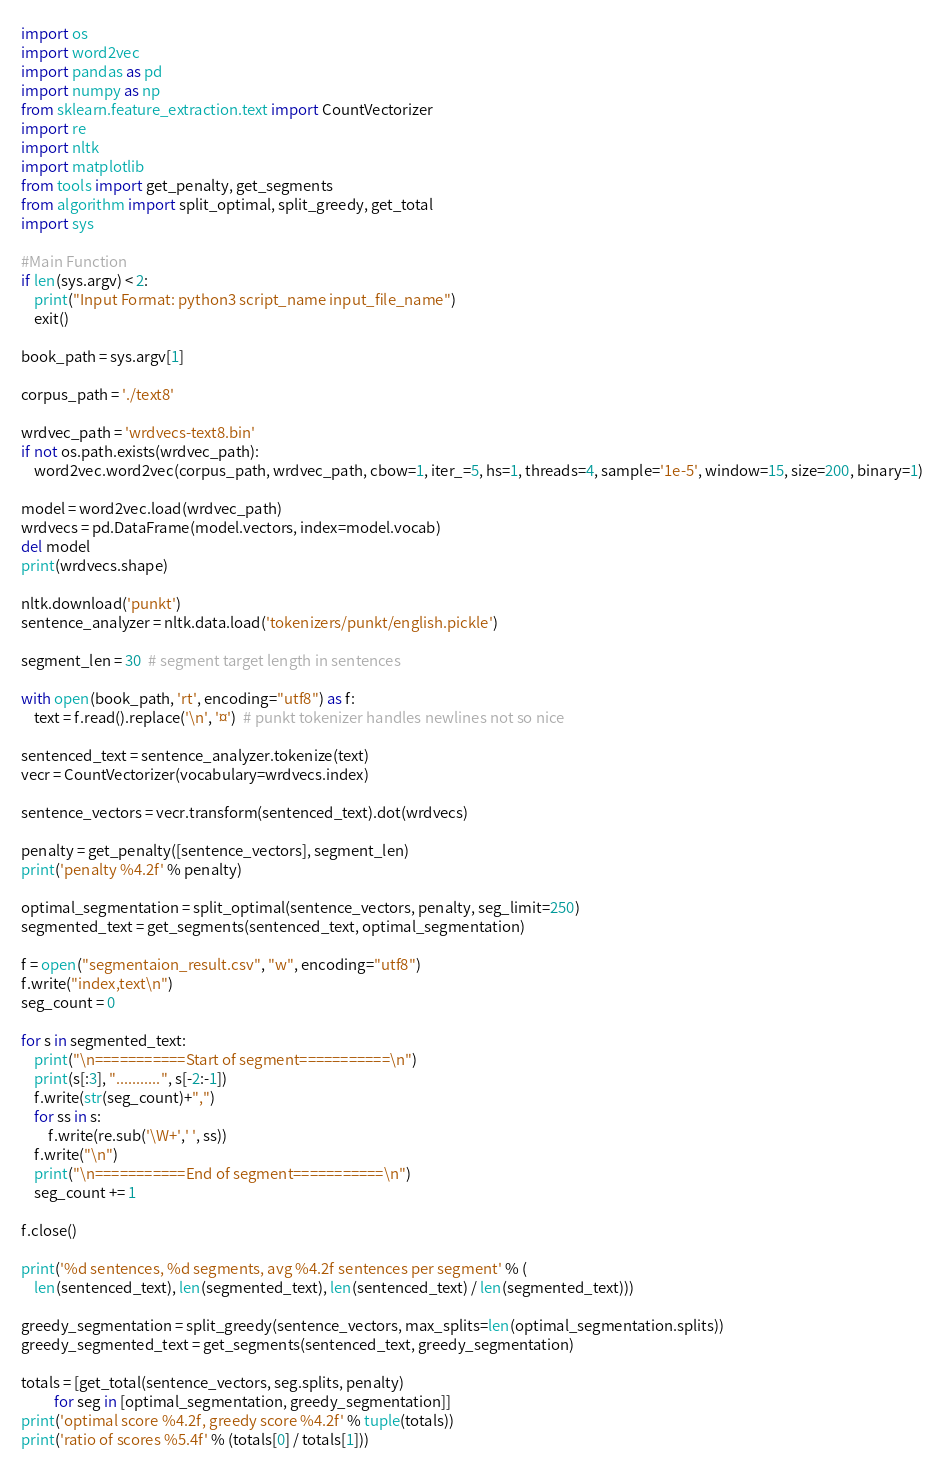Convert code to text. <code><loc_0><loc_0><loc_500><loc_500><_Python_>import os
import word2vec
import pandas as pd
import numpy as np
from sklearn.feature_extraction.text import CountVectorizer
import re
import nltk
import matplotlib
from tools import get_penalty, get_segments
from algorithm import split_optimal, split_greedy, get_total
import sys

#Main Function
if len(sys.argv) < 2:
    print("Input Format: python3 script_name input_file_name")
    exit()
    
book_path = sys.argv[1]

corpus_path = './text8'  

wrdvec_path = 'wrdvecs-text8.bin'
if not os.path.exists(wrdvec_path):
    word2vec.word2vec(corpus_path, wrdvec_path, cbow=1, iter_=5, hs=1, threads=4, sample='1e-5', window=15, size=200, binary=1)

model = word2vec.load(wrdvec_path)
wrdvecs = pd.DataFrame(model.vectors, index=model.vocab)
del model
print(wrdvecs.shape)

nltk.download('punkt')
sentence_analyzer = nltk.data.load('tokenizers/punkt/english.pickle')

segment_len = 30  # segment target length in sentences

with open(book_path, 'rt', encoding="utf8") as f:
    text = f.read().replace('\n', '¤')  # punkt tokenizer handles newlines not so nice

sentenced_text = sentence_analyzer.tokenize(text)
vecr = CountVectorizer(vocabulary=wrdvecs.index)

sentence_vectors = vecr.transform(sentenced_text).dot(wrdvecs)

penalty = get_penalty([sentence_vectors], segment_len)
print('penalty %4.2f' % penalty)

optimal_segmentation = split_optimal(sentence_vectors, penalty, seg_limit=250)
segmented_text = get_segments(sentenced_text, optimal_segmentation)

f = open("segmentaion_result.csv", "w", encoding="utf8")
f.write("index,text\n")
seg_count = 0

for s in segmented_text:
    print("\n===========Start of segment===========\n")
    print(s[:3], "...........", s[-2:-1])
    f.write(str(seg_count)+",")
    for ss in s:
        f.write(re.sub('\W+',' ', ss))
    f.write("\n")    
    print("\n===========End of segment===========\n")
    seg_count += 1

f.close()

print('%d sentences, %d segments, avg %4.2f sentences per segment' % (
    len(sentenced_text), len(segmented_text), len(sentenced_text) / len(segmented_text)))

greedy_segmentation = split_greedy(sentence_vectors, max_splits=len(optimal_segmentation.splits))
greedy_segmented_text = get_segments(sentenced_text, greedy_segmentation)

totals = [get_total(sentence_vectors, seg.splits, penalty) 
          for seg in [optimal_segmentation, greedy_segmentation]]
print('optimal score %4.2f, greedy score %4.2f' % tuple(totals))
print('ratio of scores %5.4f' % (totals[0] / totals[1]))</code> 